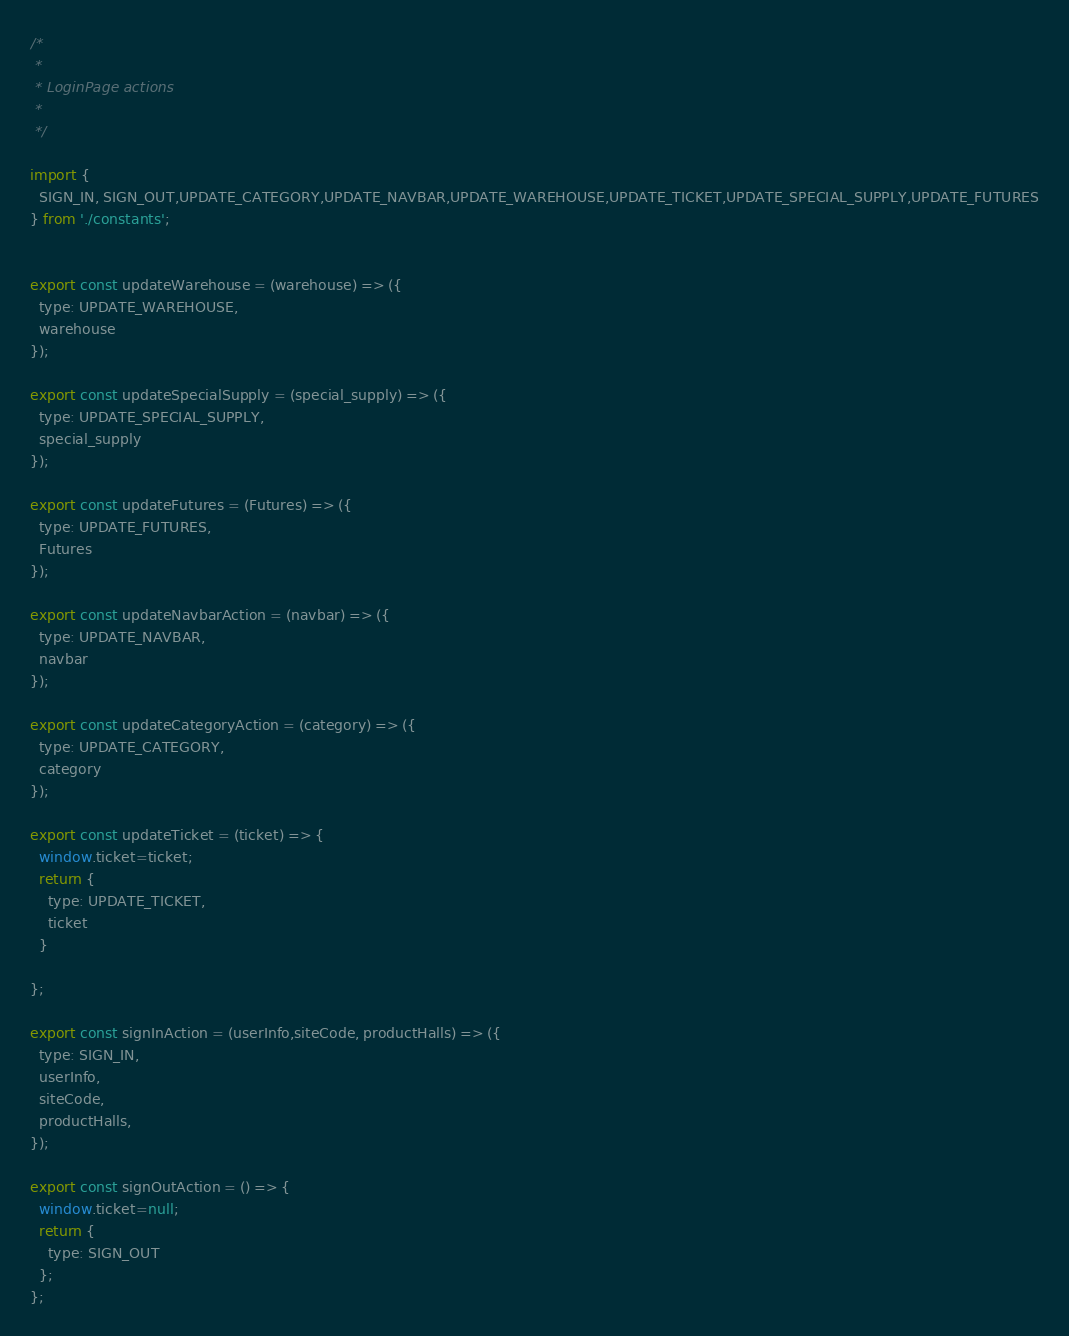Convert code to text. <code><loc_0><loc_0><loc_500><loc_500><_JavaScript_>/*
 *
 * LoginPage actions
 *
 */

import {
  SIGN_IN, SIGN_OUT,UPDATE_CATEGORY,UPDATE_NAVBAR,UPDATE_WAREHOUSE,UPDATE_TICKET,UPDATE_SPECIAL_SUPPLY,UPDATE_FUTURES
} from './constants';


export const updateWarehouse = (warehouse) => ({
  type: UPDATE_WAREHOUSE,
  warehouse
});

export const updateSpecialSupply = (special_supply) => ({
  type: UPDATE_SPECIAL_SUPPLY,
  special_supply
});

export const updateFutures = (Futures) => ({
  type: UPDATE_FUTURES,
  Futures
});

export const updateNavbarAction = (navbar) => ({
  type: UPDATE_NAVBAR,
  navbar
});

export const updateCategoryAction = (category) => ({
  type: UPDATE_CATEGORY,
  category
});

export const updateTicket = (ticket) => {
  window.ticket=ticket;
  return {
    type: UPDATE_TICKET,
    ticket
  }

};

export const signInAction = (userInfo,siteCode, productHalls) => ({
  type: SIGN_IN,
  userInfo,
  siteCode,
  productHalls,
});

export const signOutAction = () => {
  window.ticket=null;
  return {
    type: SIGN_OUT
  };
};

</code> 